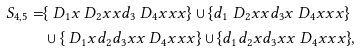<formula> <loc_0><loc_0><loc_500><loc_500>S _ { 4 , 5 } = & \{ \ D _ { 1 } x \ D _ { 2 } x x d _ { 3 } \ D _ { 4 } x x x \} \cup \{ d _ { 1 } \ D _ { 2 } x x d _ { 3 } x \ D _ { 4 } x x x \} \\ & \cup \{ \ D _ { 1 } x d _ { 2 } d _ { 3 } x x \ D _ { 4 } x x x \} \cup \{ d _ { 1 } d _ { 2 } x d _ { 3 } x x \ D _ { 4 } x x x \} ,</formula> 